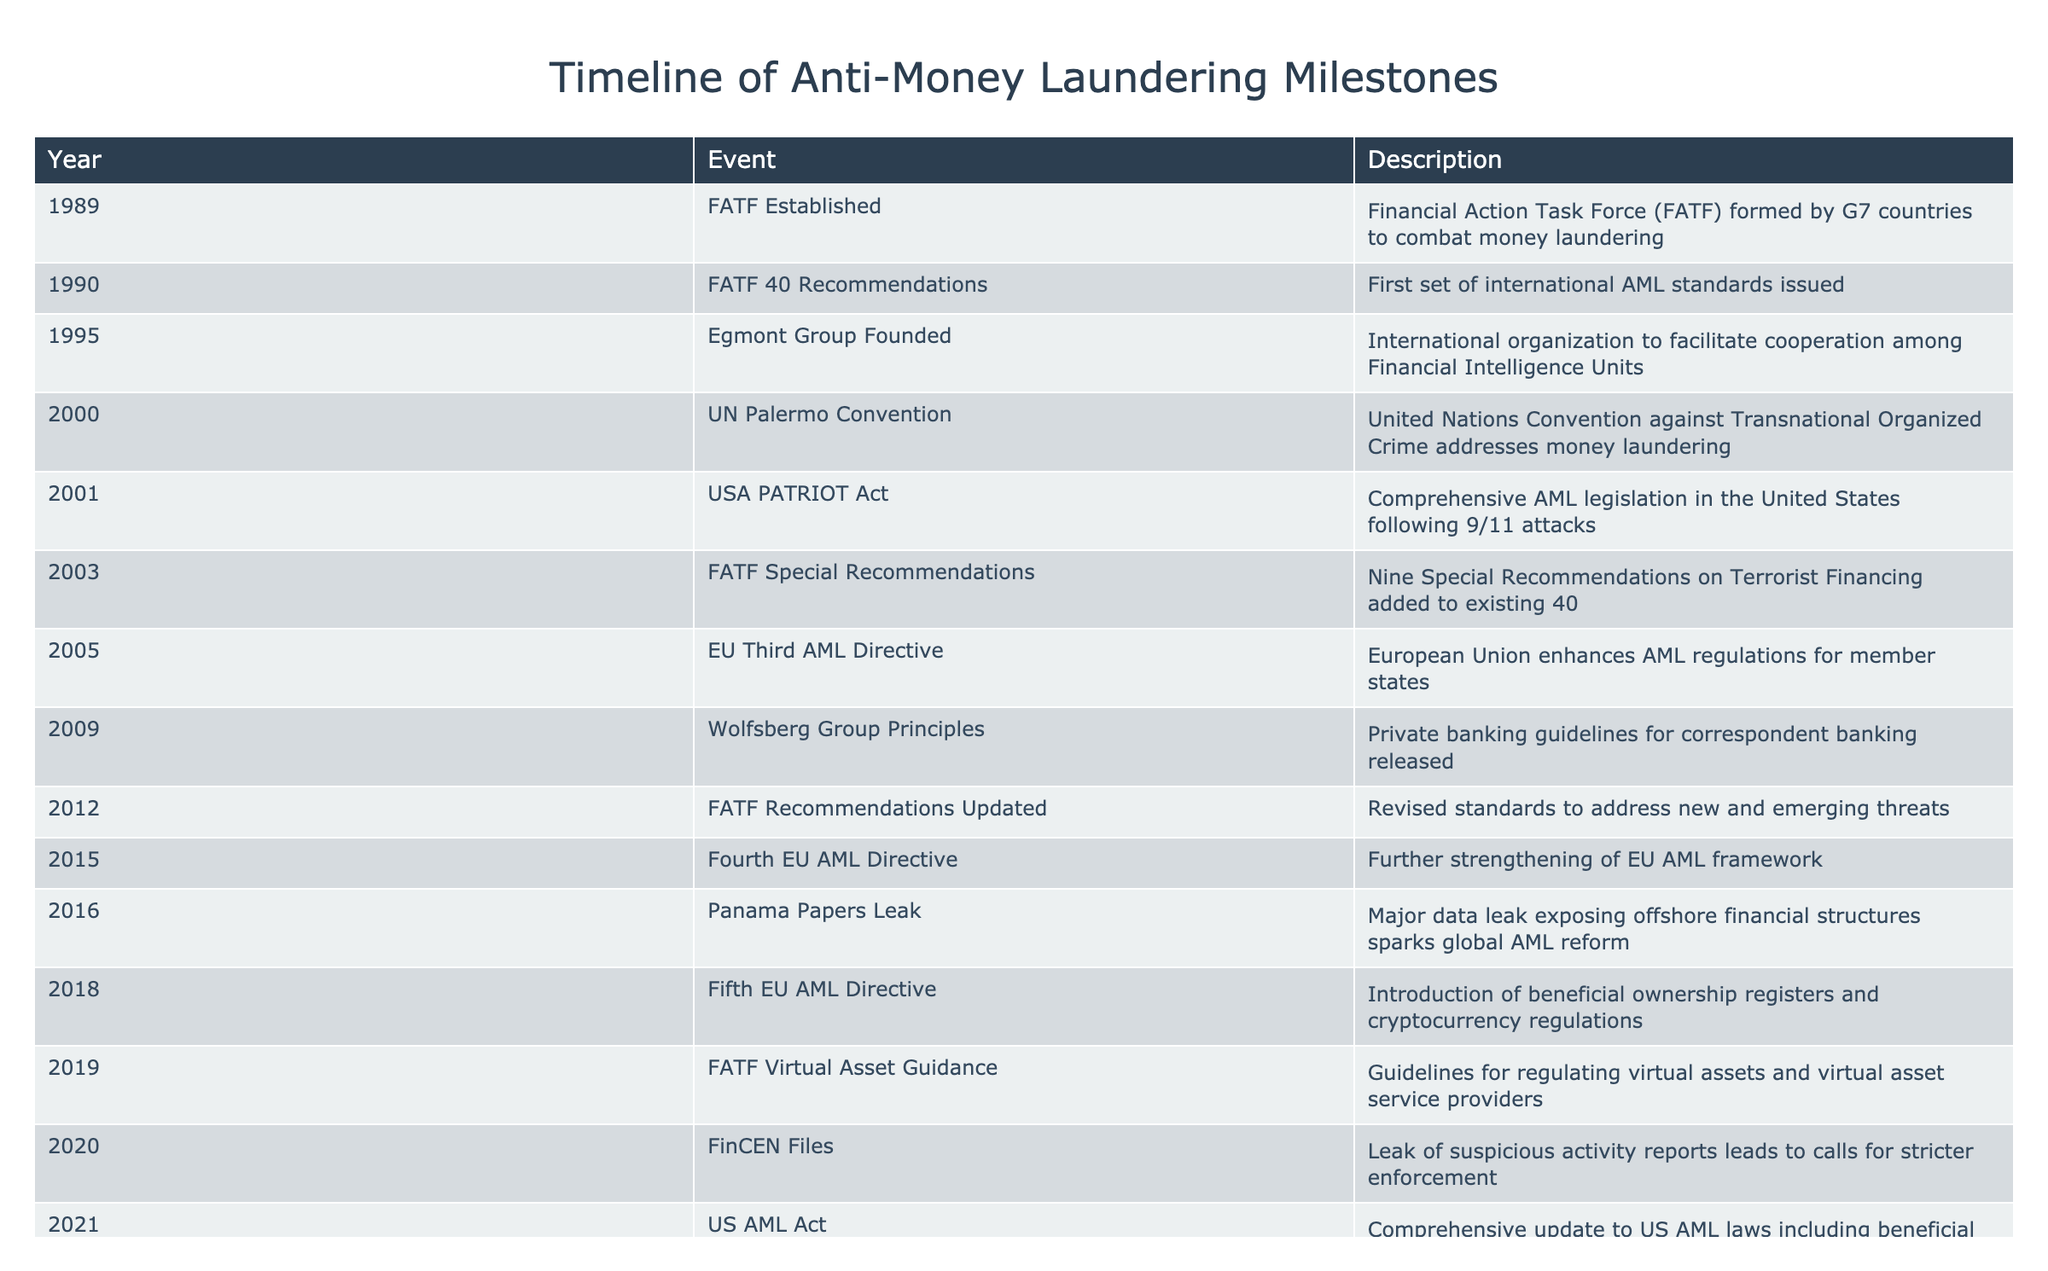What year was the FATF established? The table indicates that the FATF was established in 1989. This information can be found in the first row of the table, where the year and event are listed.
Answer: 1989 What event did the USA PATRIOT Act coincide with in terms of global context? The USA PATRIOT Act was enacted in 2001, shortly after the 9/11 attacks, which is a significant event in global security and prompted comprehensive AML legislation. There is a specific note in the description for the year 2001 that acknowledges this context.
Answer: 9/11 attacks How many years apart were the FATF Recommendations updated from the first set of recommendations issued? The initial FATF recommendations were issued in 1990 and updated in 2012. Calculating the difference: 2012 - 1990 = 22 years. This involves identifying the years given in the table and doing a simple subtraction.
Answer: 22 years Did the EU release any directives on AML regulations between 2005 and 2018? Yes, the table lists the EU Third AML Directive in 2005 and the Fifth EU AML Directive in 2018. This indicates that there were updates in AML regulations by the EU in that time frame, confirming that directives were indeed released.
Answer: Yes What major event in 2016 influenced global AML reforms? The table states that in 2016, the Panama Papers leak exposed offshore financial structures, which significantly impacted global AML reform discussions and initiatives. This inference is made by gathering context around the event listed in the specified year.
Answer: Panama Papers Leak In what year did the Fourth EU AML Directive come into effect, following the 2012 updates? The table shows that the Fourth EU AML Directive was issued in 2015, which is three years after the FATF recommendations were updated in 2012 (2015 - 2012 = 3). This requires reviewing the years of the related events to find the corresponding timeline links.
Answer: 2015 How many major international organizations or groups aimed at enhancing AML efforts were founded or established between 1989 and 2012 mentioned in the table? The table mentions three organizations/events related to AML established before 2012: FATF (1989), Egmont Group (1995), and the updated FATF recommendations (2012). Therefore, counting these instances gives us a total of three organizations relevant to the topic.
Answer: 3 Was there a connection between the FinCEN Files leak and the urgency for stricter enforcement? Yes, according to the table, the leak of FinCEN Files in 2020 led to calls for stricter enforcement of AML measures, as highlighted in the description of that year. The connection is established through the explanation in the table stating the consequence of that event.
Answer: Yes What significant guideline regarding virtual assets was provided by FATF and in what year? The FATF released guidelines for regulating virtual assets in 2019, as indicated in the table. This information is directly stated in the description for that year under the event listing, clarifying the focus on virtual asset regulation.
Answer: 2019 